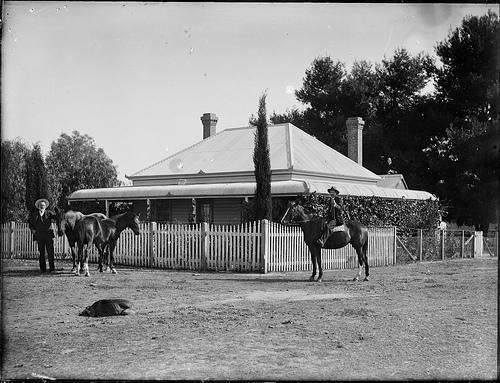How many horses are pictured?
Give a very brief answer. 3. How many horses are there?
Give a very brief answer. 2. 